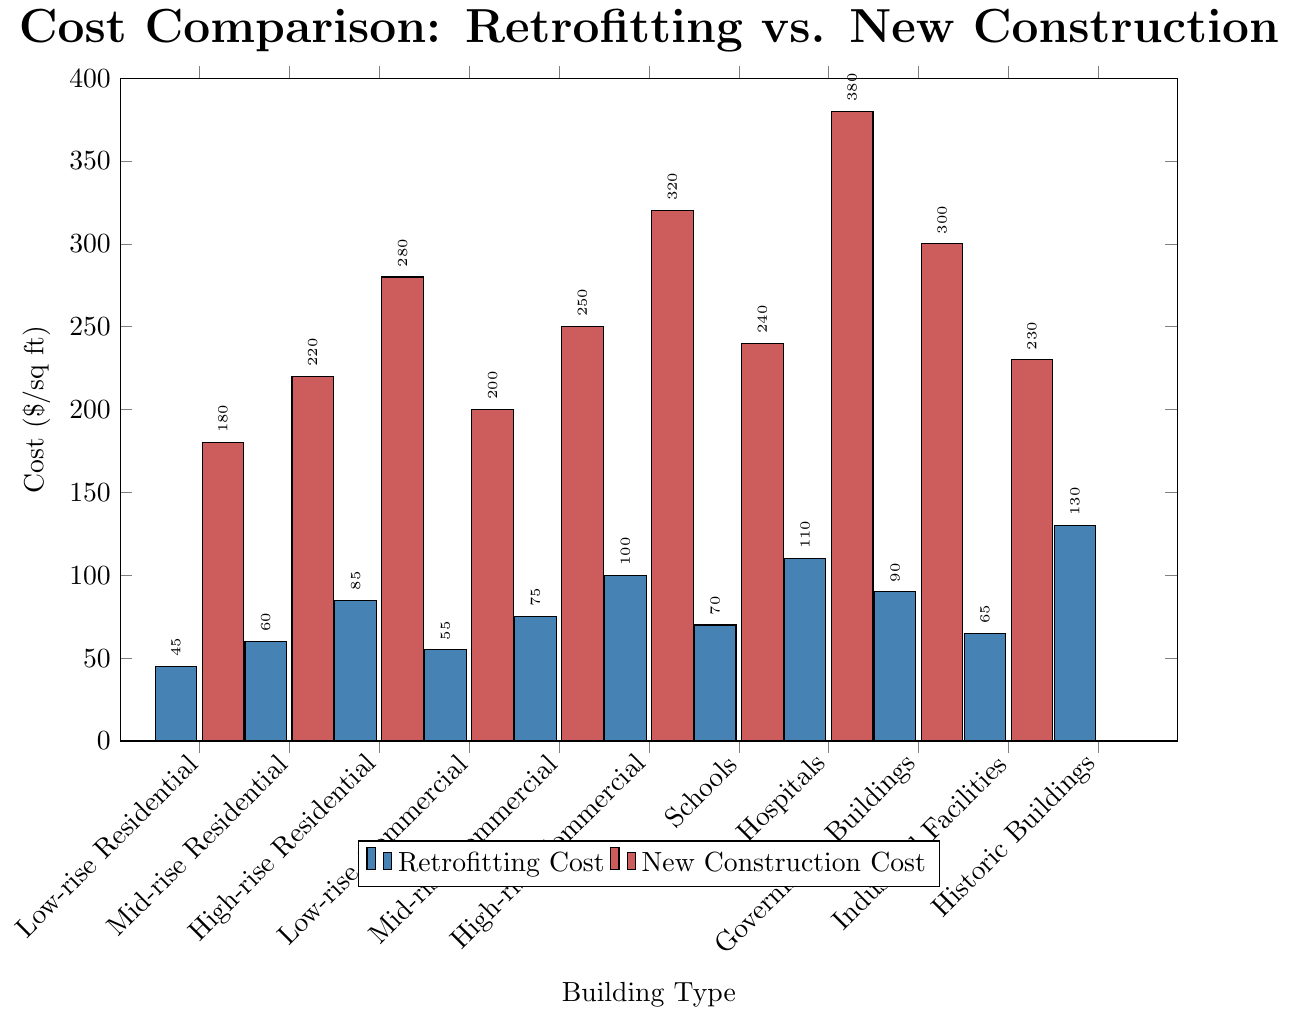Which building type has the highest retrofitting cost? Looking at the chart, the bar representing Historic Buildings in the Retrofitting Cost series is the tallest, indicating the highest cost.
Answer: Historic Buildings Which building type has the lowest new construction cost? Observing the chart, the bar for Low-rise Residential in the New Construction Cost series is the shortest, indicating the lowest cost.
Answer: Low-rise Residential How much more does it cost to retrofit a hospital compared to a low-rise residential building? The cost to retrofit a hospital is $110/sq ft and a low-rise residential building is $45/sq ft. The difference is $110 - $45 = $65.
Answer: $65 What is the difference in cost between retrofitting and constructing new high-rise commercial buildings? The retrofitting cost for high-rise commercial buildings is $100/sq ft, while the new construction cost is $320/sq ft. The difference is $320 - $100 = $220.
Answer: $220 Which type of building has a closer cost range between retrofitting and new construction: schools or industrial facilities? For schools, the retrofitting cost is $70/sq ft and new construction is $240/sq ft, a difference of $240 - $70 = $170. For industrial facilities, the retrofitting cost is $65/sq ft and new construction is $230/sq ft, a difference of $230 - $65 = $165. The range is closer for industrial facilities.
Answer: Industrial Facilities What is the average cost of retrofitting government buildings and hospitals? The retrofitting cost of government buildings is $90/sq ft and hospitals is $110/sq ft. The average is ($90 + $110) / 2 = $100.
Answer: $100 If the total cost to retrofit ten mid-rise residential buildings equals the cost to construct two new schools, how many square feet do all mid-rise residential buildings cover? The cost to retrofit one mid-rise residential building is $60/sq ft, and for ten buildings, it's 10 * $60 = $600/sq ft. The cost to construct one new school is $240/sq ft, and for two schools, it's 2 * $240 = $480/sq ft. Therefore, the total square footage of the mid-rise residential buildings is 480 / 60 = 8.
Answer: 8 Which building type has the greatest difference between retrofitting and new construction costs? By visually comparing the height difference of the bars, Hospitals have the greatest difference between retrofitting ($110) and new construction ($380). The difference is $380 - $110 = $270.
Answer: Hospitals How many building types have retrofitting costs greater than $60 but less than $100 per square foot? The building types with retrofitting costs in this range are Mid-rise Residential ($60), Low-rise Commercial ($55), Mid-rise Commercial ($75), Schools ($70), Industrial Facilities ($65).
Answer: 5 What is the combined retrofitting cost of low-rise and mid-rise residential buildings? The retrofitting cost for low-rise residential is $45/sq ft and mid-rise residential is $60/sq ft. Combined, it's $45 + $60 = $105.
Answer: $105 